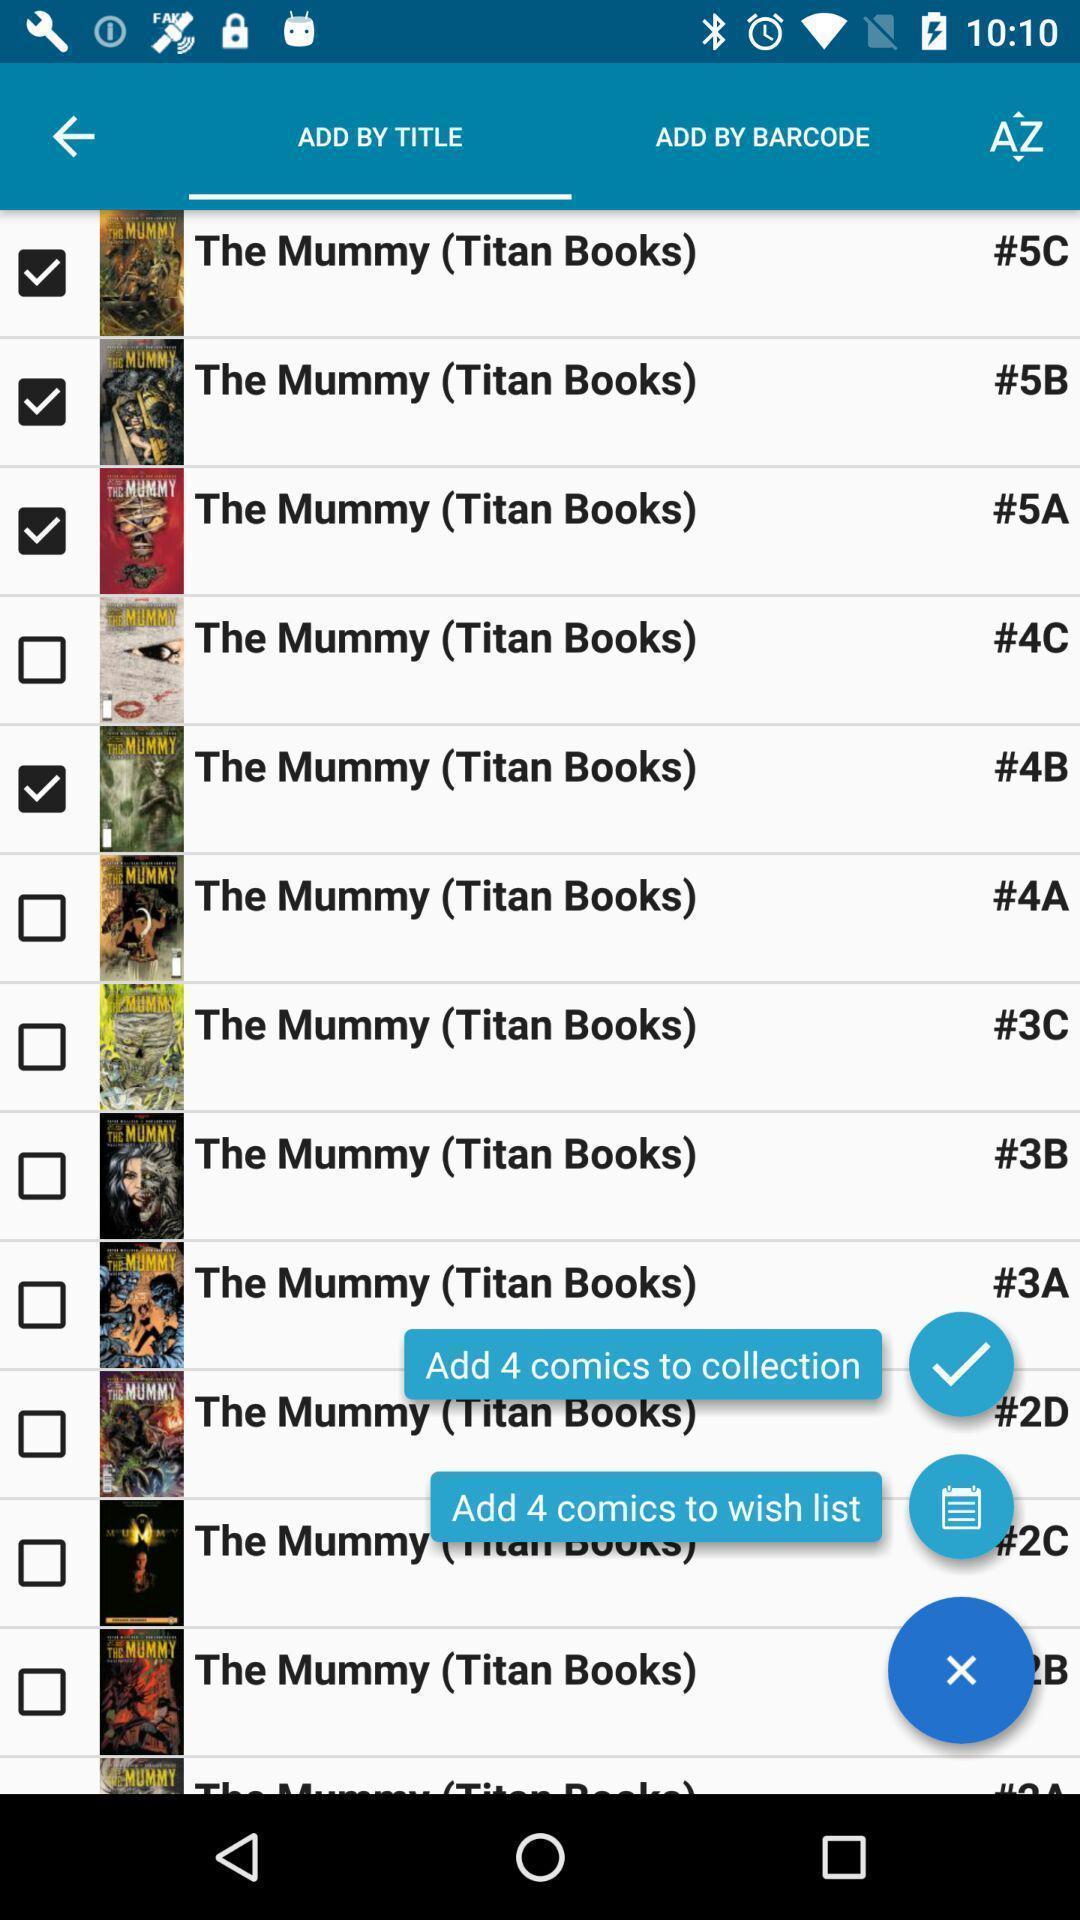Explain what's happening in this screen capture. Screen showing to add by title. 